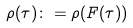Convert formula to latex. <formula><loc_0><loc_0><loc_500><loc_500>\rho ( \tau ) \colon = \rho ( F ( \tau ) )</formula> 